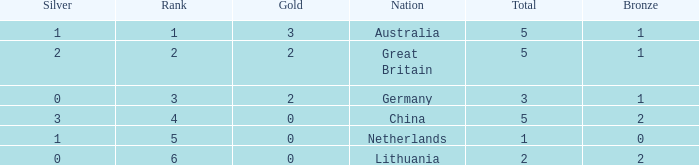What is the average for silver when bronze is less than 1, and gold is more than 0? None. 